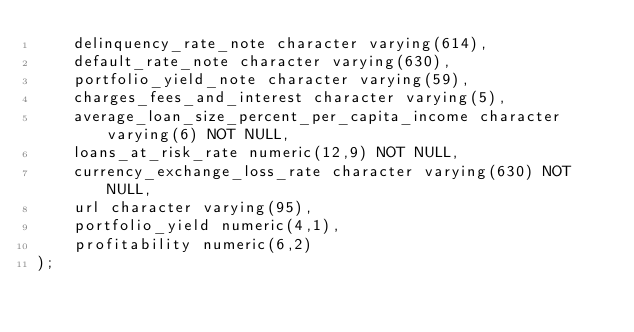Convert code to text. <code><loc_0><loc_0><loc_500><loc_500><_SQL_>    delinquency_rate_note character varying(614),
    default_rate_note character varying(630),
    portfolio_yield_note character varying(59),
    charges_fees_and_interest character varying(5),
    average_loan_size_percent_per_capita_income character varying(6) NOT NULL,
    loans_at_risk_rate numeric(12,9) NOT NULL,
    currency_exchange_loss_rate character varying(630) NOT NULL,
    url character varying(95),
    portfolio_yield numeric(4,1),
    profitability numeric(6,2)
);
</code> 